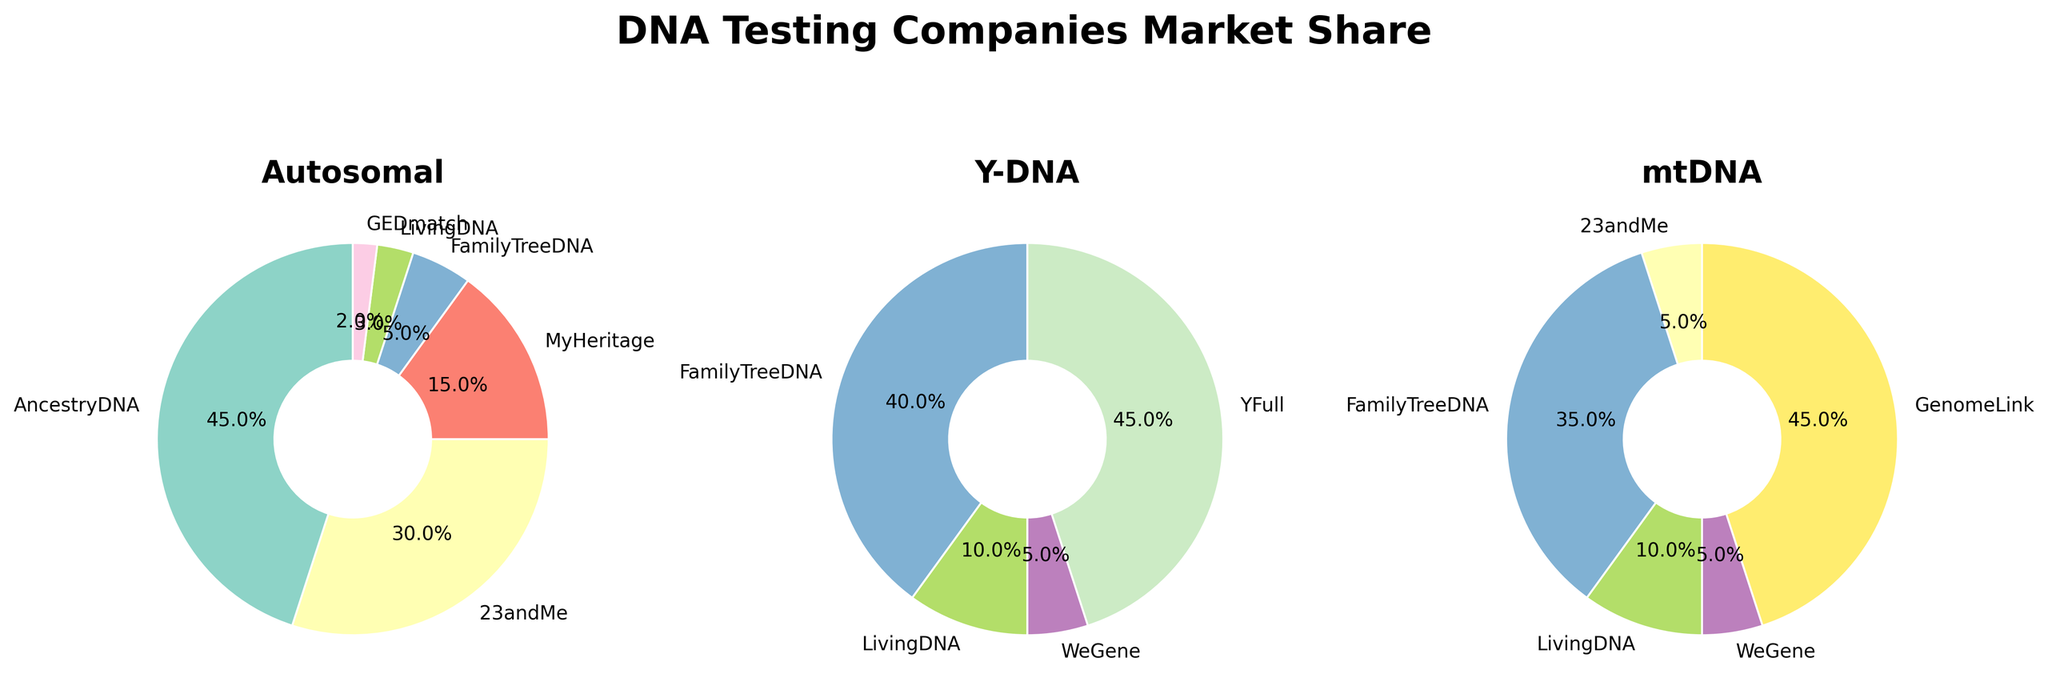How many subplots are present in the figure? The figure contains multiple subplots shown side-by-side. By visually inspecting, we see that there are three distinct pie charts.
Answer: 3 Which company has the largest market share in Autosomal tests? In the Autosomal subplot, the segment with the largest area is labeled as AncestryDNA.
Answer: AncestryDNA What is the combined market share of AncestryDNA and 23andMe in Autosomal tests? Looking at the Autosomal pie chart, AncestryDNA has a 45% share, and 23andMe has a 30% share. Adding these percentages gives us 45 + 30 = 75.
Answer: 75% Which companies are represented in all three subcategories (Autosomal, Y-DNA, mtDNA)? Analyzing all three pie charts, the only companies appearing in each category's subplot are LivingDNA.
Answer: LivingDNA What is the market share difference between Y-DNA and mtDNA tests for FamilyTreeDNA? From the Y-DNA pie chart, FamilyTreeDNA has a 40% share. From the mtDNA pie chart, it holds 35%. The difference is 40 - 35 = 5.
Answer: 5% In which subcategory does GenomeLink appear, and what is its market share there? GenomeLink is not present in the Autosomal and Y-DNA subplots. It only appears in the mtDNA pie chart with a market share of 45%.
Answer: mtDNA, 45% Which company has no market share in Autosomal tests but has the highest market share in another subcategory? YFull has no slice in the Autosomal pie chart and has the highest market share in the Y-DNA pie chart with 45%.
Answer: YFull What is the total market share for WeGene across all subcategories? WeGene's market share is visually not present in Autosomal, 5% in Y-DNA, and 5% in mtDNA. Adding these gives us 0 + 5 + 5 = 10.
Answer: 10% What proportion of the Y-DNA market do YFull and FamilyTreeDNA together occupy? Y-DNA pie: YFull has 45% and FamilyTreeDNA has 40%. Combined share is 45 + 40 = 85.
Answer: 85% Which subcategory has more companies with nonzero market share: Autosomal or Y-DNA? Autosomal subplot: AncestryDNA, 23andMe, MyHeritage, FamilyTreeDNA, LivingDNA, GEDmatch = 6. Y-DNA subplot: FamilyTreeDNA, LivingDNA, WeGene, YFull = 4. 6 > 4.
Answer: Autosomal 